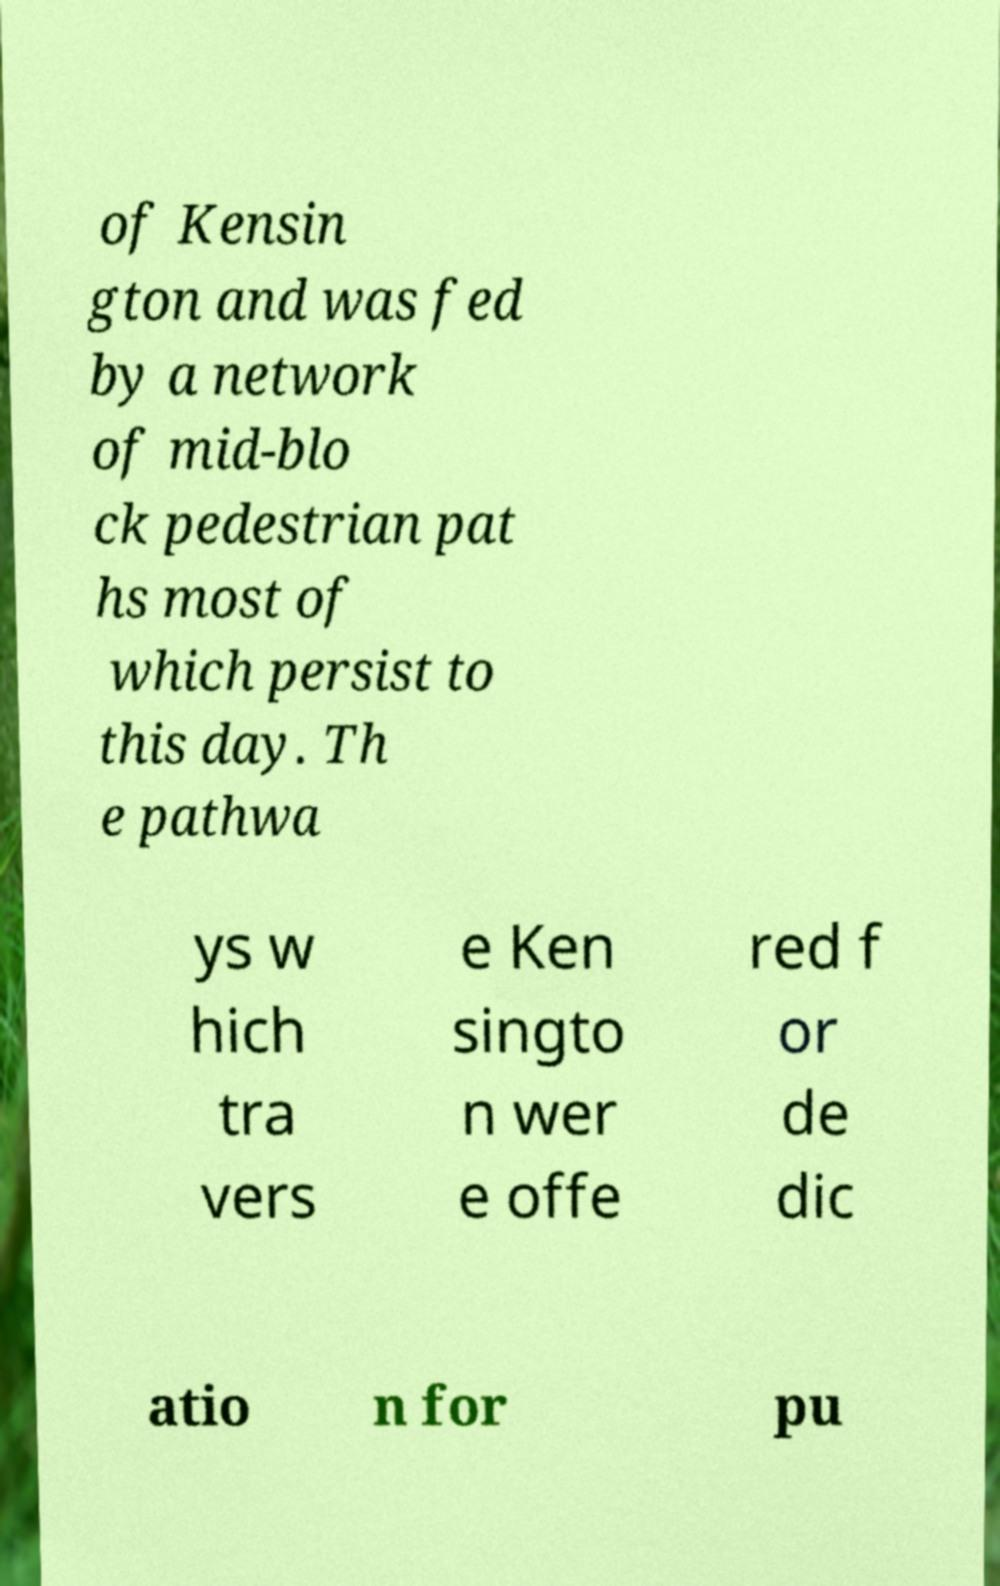What messages or text are displayed in this image? I need them in a readable, typed format. of Kensin gton and was fed by a network of mid-blo ck pedestrian pat hs most of which persist to this day. Th e pathwa ys w hich tra vers e Ken singto n wer e offe red f or de dic atio n for pu 